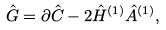<formula> <loc_0><loc_0><loc_500><loc_500>\hat { G } = \partial \hat { C } - 2 \hat { H } ^ { ( 1 ) } \hat { A } ^ { ( 1 ) } ,</formula> 